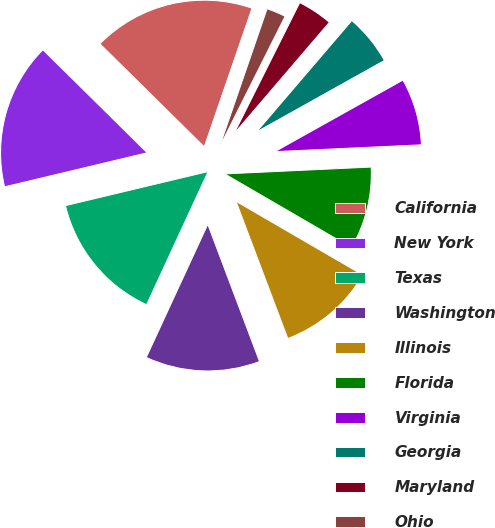<chart> <loc_0><loc_0><loc_500><loc_500><pie_chart><fcel>California<fcel>New York<fcel>Texas<fcel>Washington<fcel>Illinois<fcel>Florida<fcel>Virginia<fcel>Georgia<fcel>Maryland<fcel>Ohio<nl><fcel>17.88%<fcel>16.13%<fcel>14.38%<fcel>12.63%<fcel>10.88%<fcel>9.12%<fcel>7.37%<fcel>5.62%<fcel>3.87%<fcel>2.12%<nl></chart> 